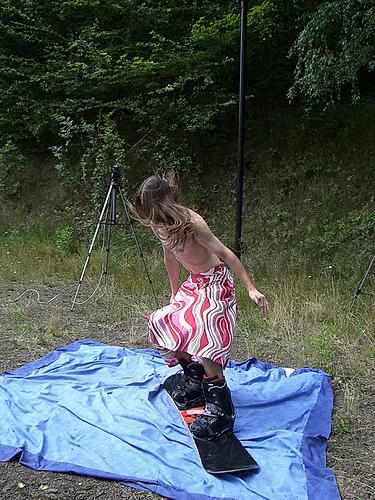Question: what color is the boy's hair?
Choices:
A. Blonde.
B. Red.
C. Black.
D. Brown.
Answer with the letter. Answer: A Question: what time is this taking place?
Choices:
A. Morning.
B. Breakfast.
C. Daytime.
D. Afternoon.
Answer with the letter. Answer: C Question: what is the color of the boy's skin?
Choices:
A. Pale.
B. Tan.
C. Freckled.
D. White.
Answer with the letter. Answer: D Question: what is the color of the blanket under the kid?
Choices:
A. Black.
B. Purple.
C. Blue.
D. Brown.
Answer with the letter. Answer: C 